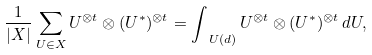Convert formula to latex. <formula><loc_0><loc_0><loc_500><loc_500>\frac { 1 } { | X | } \sum _ { U \in X } U ^ { \otimes t } \otimes ( U ^ { * } ) ^ { \otimes t } = \int _ { \ U ( d ) } U ^ { \otimes t } \otimes ( U ^ { * } ) ^ { \otimes t } \, d U ,</formula> 